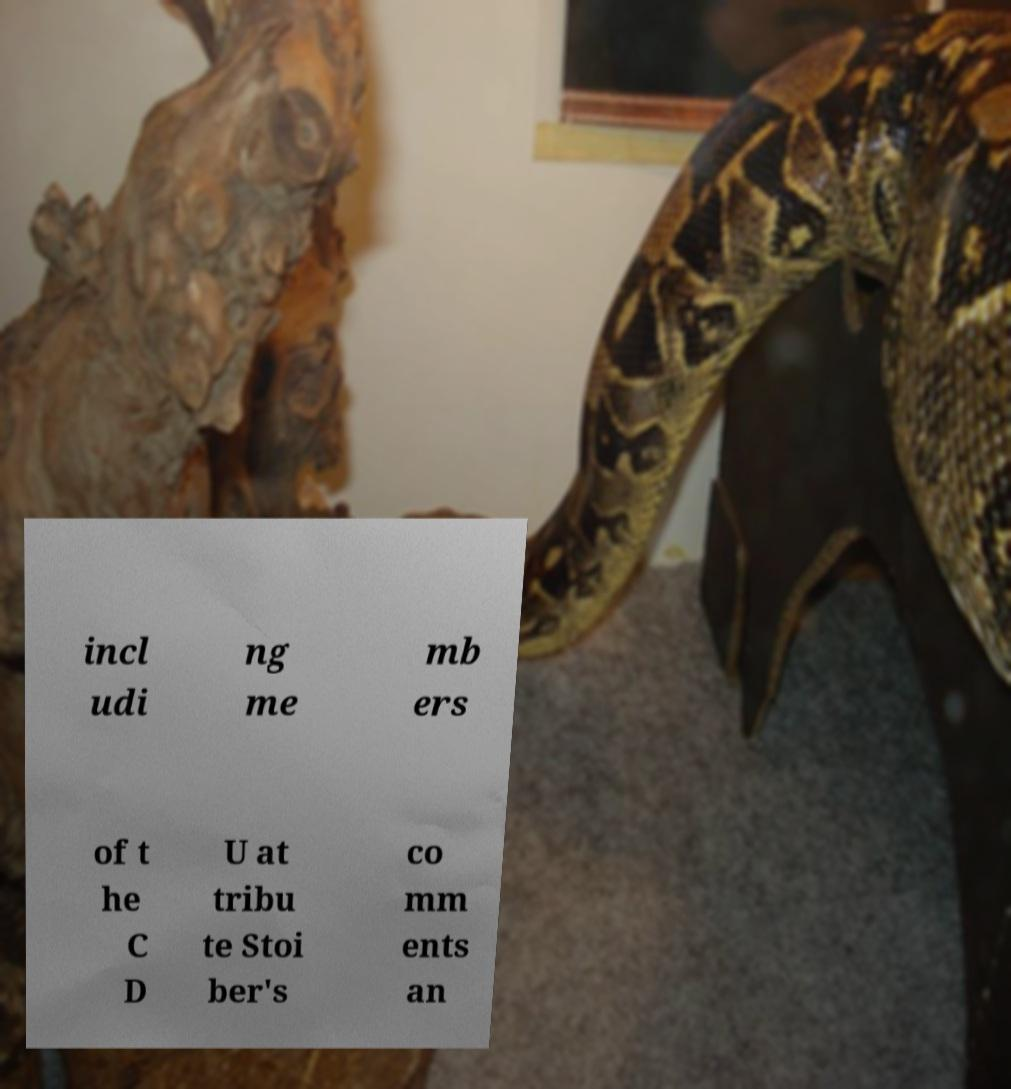Can you read and provide the text displayed in the image?This photo seems to have some interesting text. Can you extract and type it out for me? incl udi ng me mb ers of t he C D U at tribu te Stoi ber's co mm ents an 